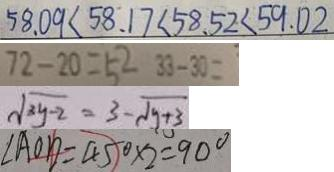<formula> <loc_0><loc_0><loc_500><loc_500>5 8 . 0 9 < 5 8 . 1 7 < 5 8 . 5 2 < 5 9 . 0 2 
 7 2 - 2 0 = 5 2 3 3 - 3 0 = 
 \sqrt { 3 y - 2 } = 3 - \sqrt { y + 3 } 
 \angle A O D = 4 5 ^ { \circ } \times 2 = 9 0 ^ { \circ }</formula> 